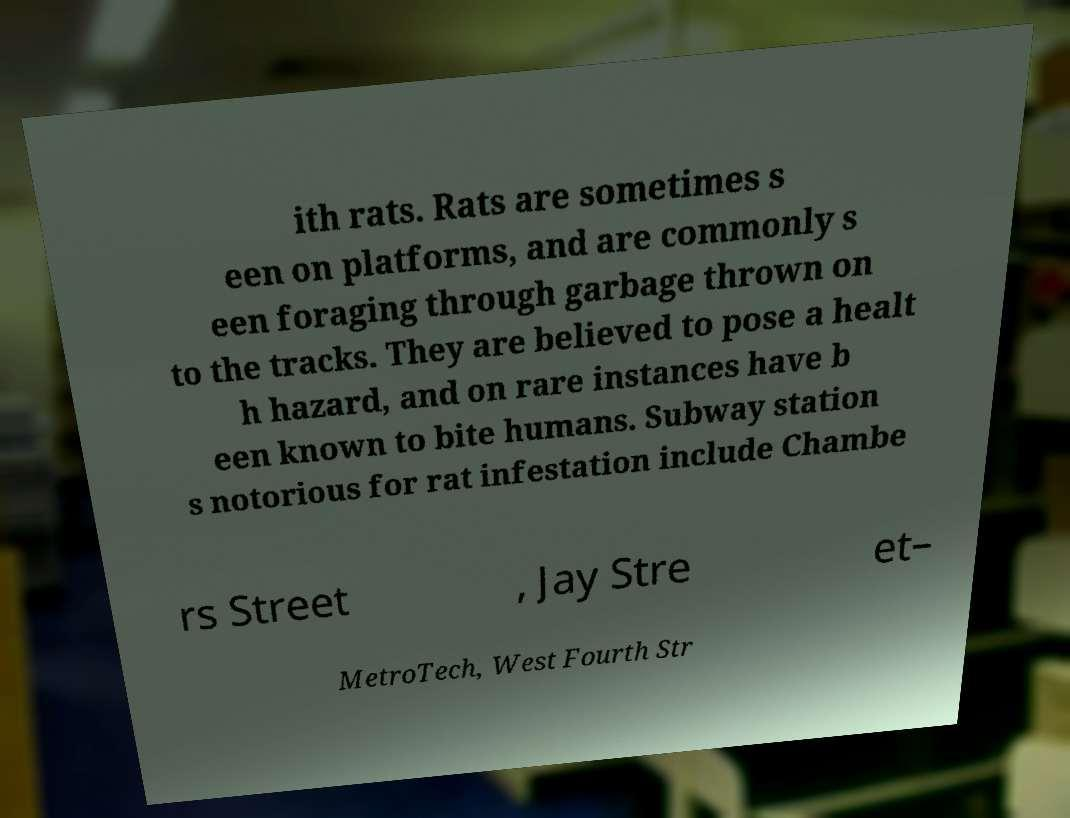Please read and relay the text visible in this image. What does it say? ith rats. Rats are sometimes s een on platforms, and are commonly s een foraging through garbage thrown on to the tracks. They are believed to pose a healt h hazard, and on rare instances have b een known to bite humans. Subway station s notorious for rat infestation include Chambe rs Street , Jay Stre et– MetroTech, West Fourth Str 